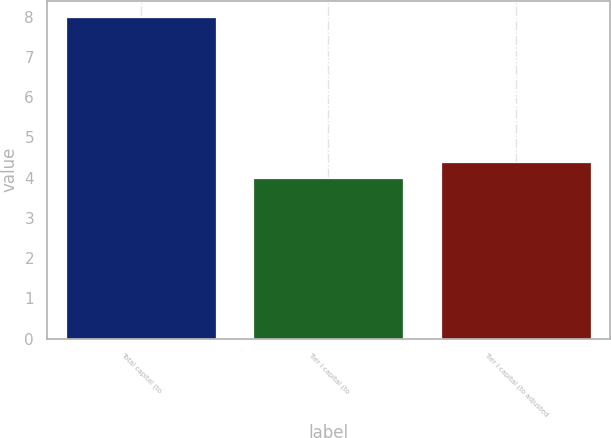Convert chart. <chart><loc_0><loc_0><loc_500><loc_500><bar_chart><fcel>Total capital (to<fcel>Tier I capital (to<fcel>Tier I capital (to adjusted<nl><fcel>8<fcel>4<fcel>4.4<nl></chart> 